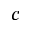<formula> <loc_0><loc_0><loc_500><loc_500>c</formula> 